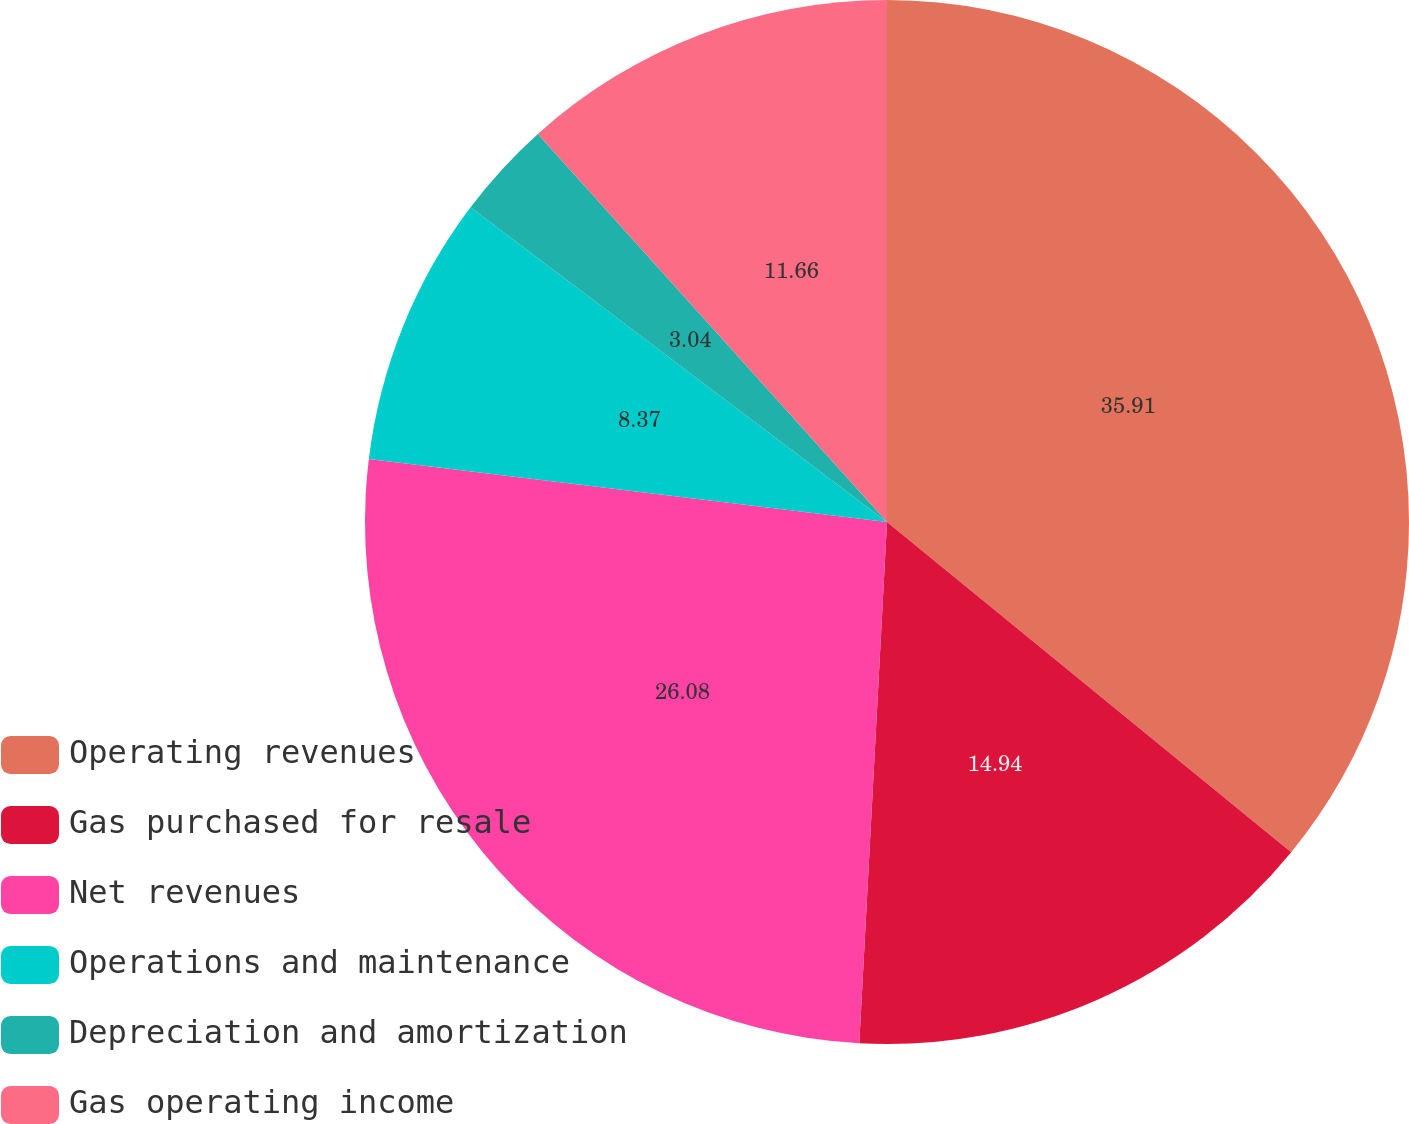<chart> <loc_0><loc_0><loc_500><loc_500><pie_chart><fcel>Operating revenues<fcel>Gas purchased for resale<fcel>Net revenues<fcel>Operations and maintenance<fcel>Depreciation and amortization<fcel>Gas operating income<nl><fcel>35.9%<fcel>14.94%<fcel>26.08%<fcel>8.37%<fcel>3.04%<fcel>11.66%<nl></chart> 